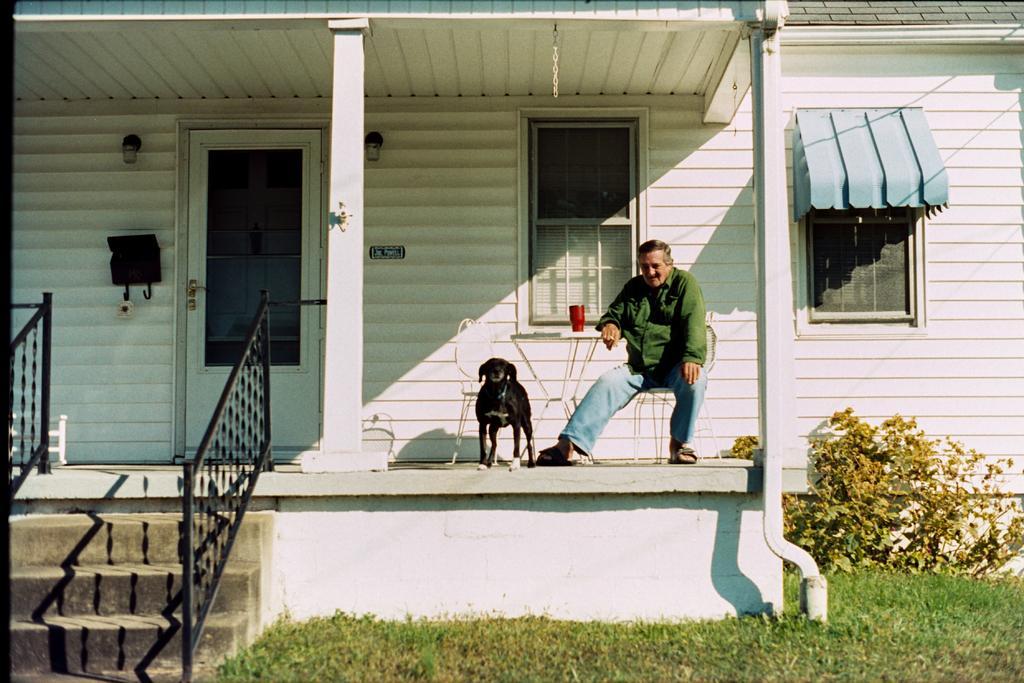Describe this image in one or two sentences. In the foreground of this picture, there is a grass and stairs and can also see the house and outside of the house, there is a chair, a man sitting on the chair, a glass on the table and a dog. On the right side, there is a tree and the grass. 